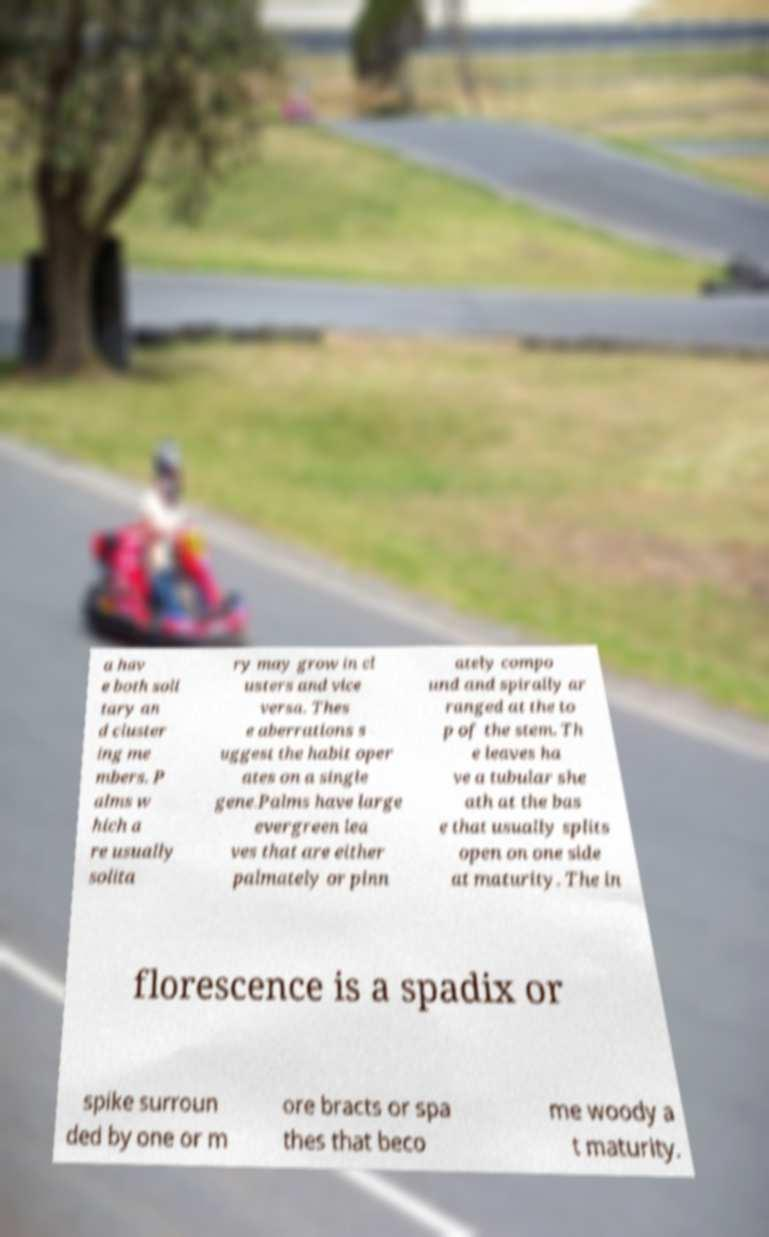Can you read and provide the text displayed in the image?This photo seems to have some interesting text. Can you extract and type it out for me? a hav e both soli tary an d cluster ing me mbers. P alms w hich a re usually solita ry may grow in cl usters and vice versa. Thes e aberrations s uggest the habit oper ates on a single gene.Palms have large evergreen lea ves that are either palmately or pinn ately compo und and spirally ar ranged at the to p of the stem. Th e leaves ha ve a tubular she ath at the bas e that usually splits open on one side at maturity. The in florescence is a spadix or spike surroun ded by one or m ore bracts or spa thes that beco me woody a t maturity. 